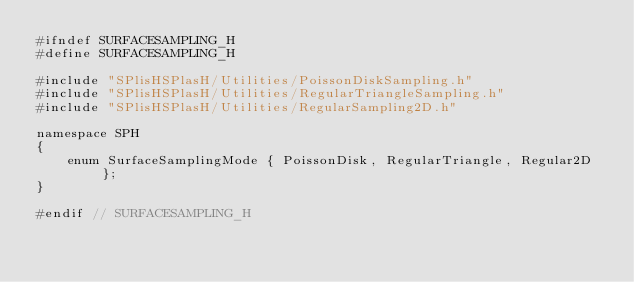<code> <loc_0><loc_0><loc_500><loc_500><_C_>#ifndef SURFACESAMPLING_H
#define SURFACESAMPLING_H

#include "SPlisHSPlasH/Utilities/PoissonDiskSampling.h"
#include "SPlisHSPlasH/Utilities/RegularTriangleSampling.h"
#include "SPlisHSPlasH/Utilities/RegularSampling2D.h"

namespace SPH
{
	enum SurfaceSamplingMode { PoissonDisk, RegularTriangle, Regular2D };
}

#endif // SURFACESAMPLING_H
</code> 